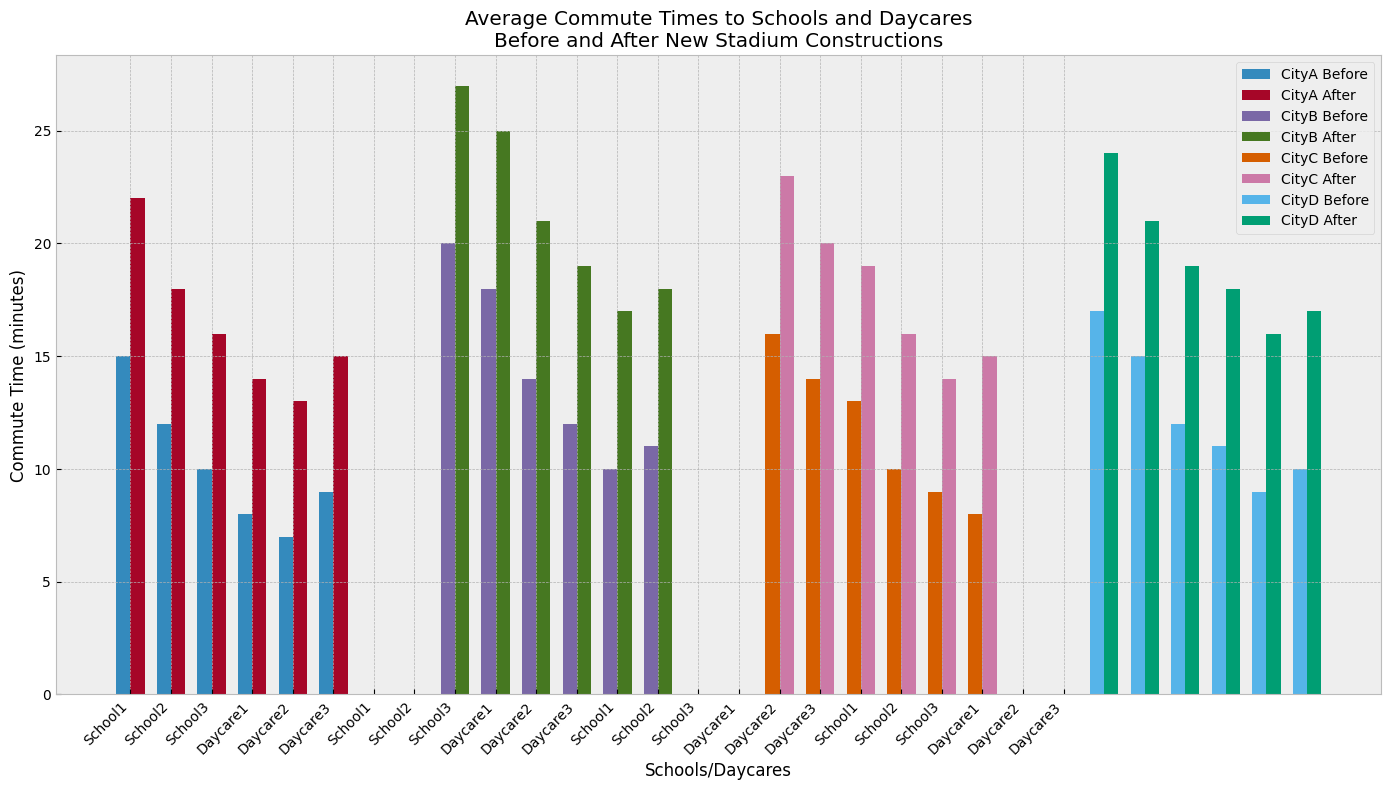How did the average commute time to School1 in CityA change after the new stadium construction? The average commute time to School1 in CityA increased from 15 minutes to 22 minutes after the new stadium construction, which can be identified by comparing the heights of the corresponding bars for "Before" and "After".
Answer: Increased from 15 to 22 minutes Which city saw the greatest increase in average commute time to the daycare centers after the new stadium constructions? CityC saw its average commute time to daycare centers increase from 9 minutes before construction (average of 10, 9, and 8) to 15 minutes after construction (average of 16, 14, and 15), which is a 6-minute increase. This is the greatest increase among all cities when comparing the average values visually from the height of the bars.
Answer: CityC Did the average commute times to schools in CityD increase uniformly after new stadium constructions? In CityD, commute times increased from 17 to 24 minutes for School1, 15 to 21 minutes for School2, and 12 to 19 minutes for School3, indicating that the increase was not uniform as each school saw a different increase. This can be discerned by comparing the heights of the bars for "Before" and "After" for each school in CityD.
Answer: No, it varied By how many minutes did the commute time to Daycare1 in CityB increase after the new stadium construction? The commute time to Daycare1 in CityB increased from 12 minutes before construction to 19 minutes after, which can be seen by comparing the height of the bars labeled Daycare1 for "Before" and "After".
Answer: 7 minutes Which school in CityA had the least increase in commute time after new stadium constructions? In CityA, School3 had the least increase, going from 10 to 16 minutes, which is a 6-minute increase. This is less than the increases for School1 and School2 when comparing bar heights.
Answer: School3 What's the average increase in commute time to daycares in CityD after stadium constructions? For CityD daycares, the increases are: Daycare1 (11 to 18 = 7 minutes), Daycare2 (9 to 16 = 7 minutes), and Daycare3 (10 to 17 = 7 minutes). The average increase is (7+7+7)/3 = 7 minutes which can be calculated by observing the differences in bar heights.
Answer: 7 minutes Which city had the smallest increase in average commute times to its schools after new stadium constructions? CityC had the smallest increase in average commute times to its schools. School1 increased by 7 minutes (16 to 23), School2 by 6 minutes (14 to 20), and School3 by 6 minutes (13 to 19). So the average increase for schools in CityC was 6.33 minutes, which is less than the increases for other cities.
Answer: CityC 